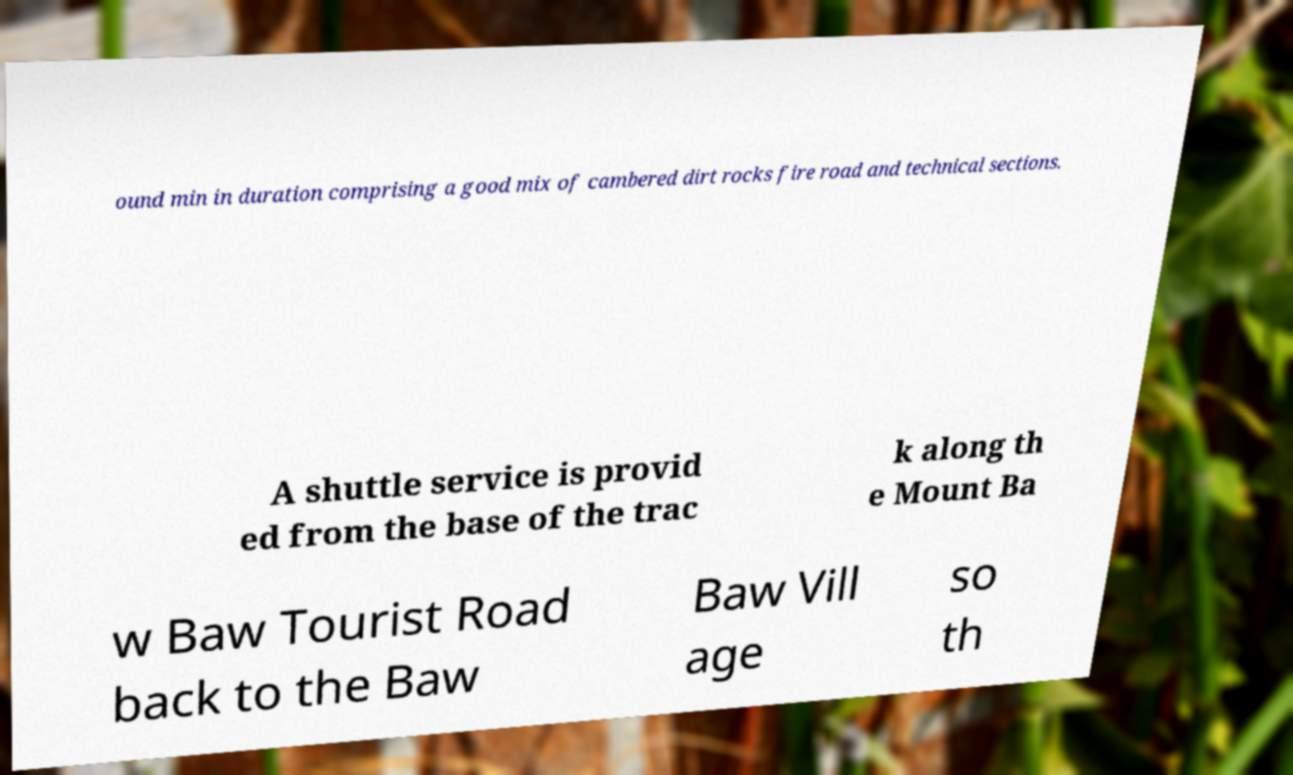Could you assist in decoding the text presented in this image and type it out clearly? ound min in duration comprising a good mix of cambered dirt rocks fire road and technical sections. A shuttle service is provid ed from the base of the trac k along th e Mount Ba w Baw Tourist Road back to the Baw Baw Vill age so th 